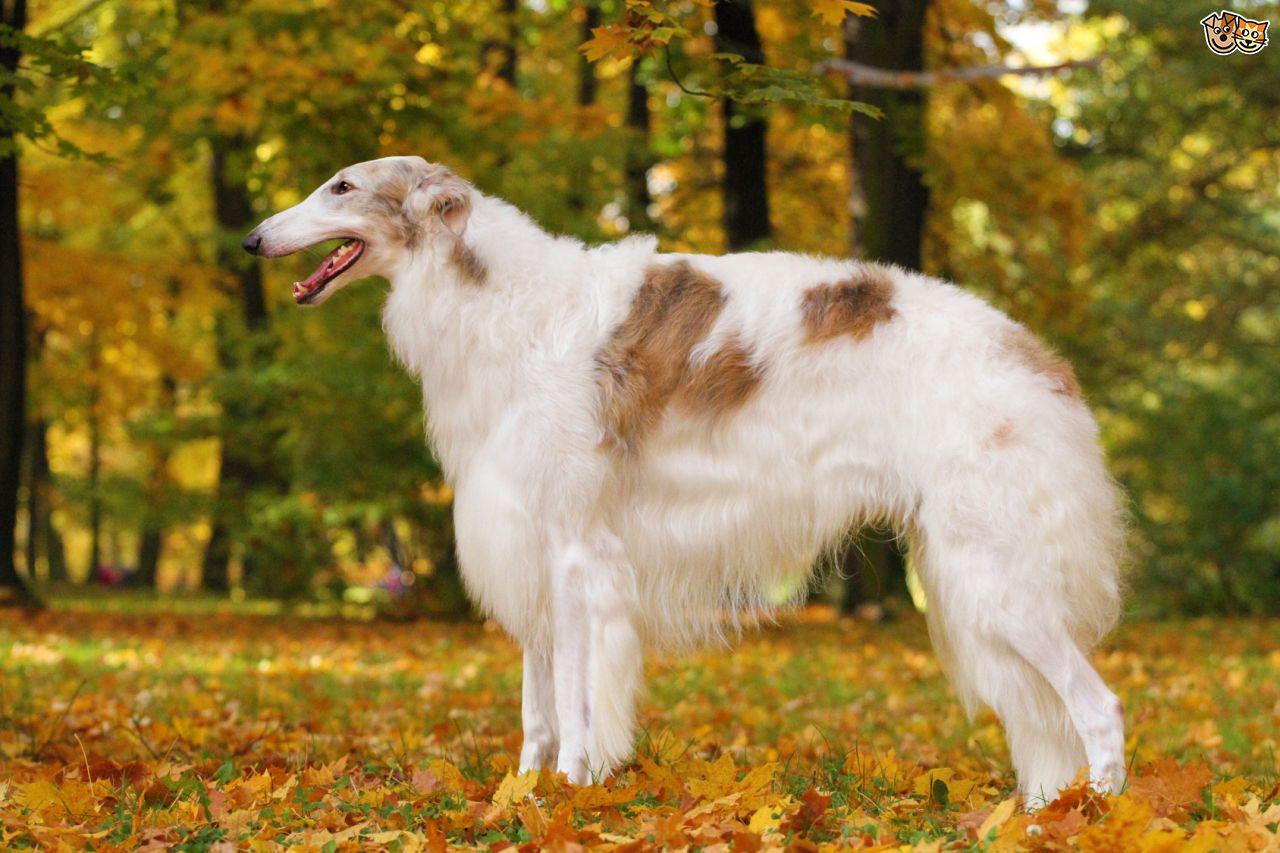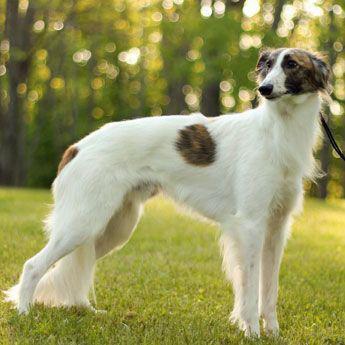The first image is the image on the left, the second image is the image on the right. Examine the images to the left and right. Is the description "The dog in the image on the left is facing left and the dog in the image on the right is facing right." accurate? Answer yes or no. Yes. 